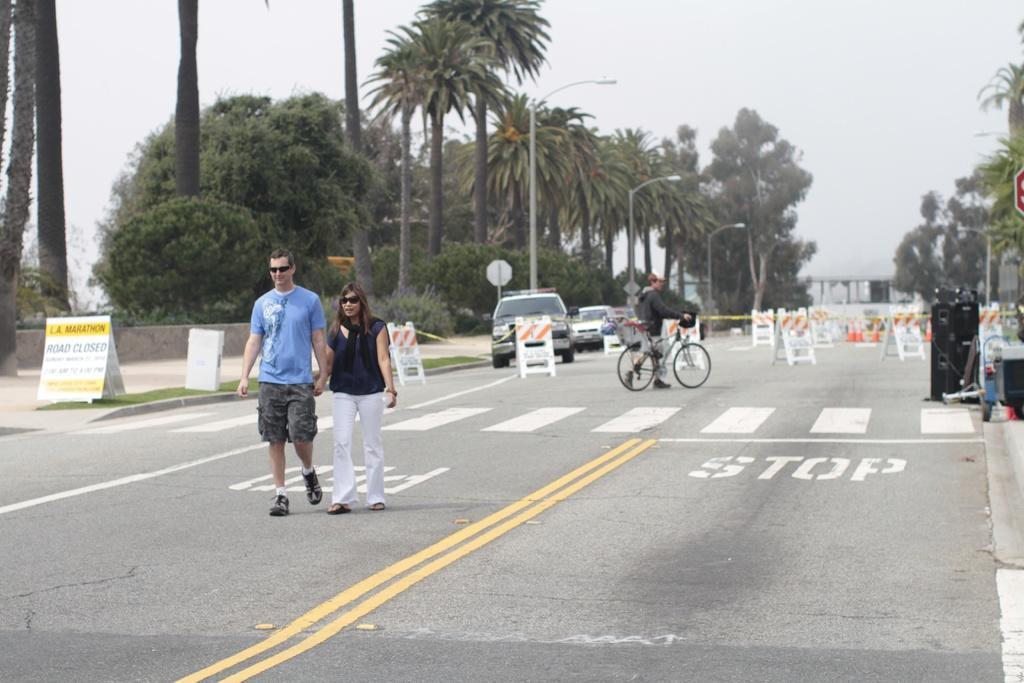Could you give a brief overview of what you see in this image? In this picture i could see some persons walking on the main road in the background i could see some trees and cloudy sky and some cars driving at the back. 